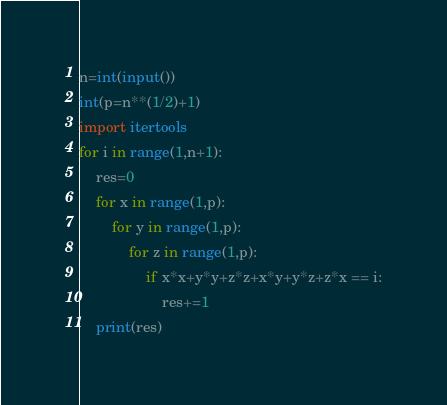Convert code to text. <code><loc_0><loc_0><loc_500><loc_500><_Python_>n=int(input())
int(p=n**(1/2)+1)
import itertools
for i in range(1,n+1):
    res=0
    for x in range(1,p):
        for y in range(1,p):
            for z in range(1,p):
                if x*x+y*y+z*z+x*y+y*z+z*x == i:
                    res+=1
    print(res)</code> 